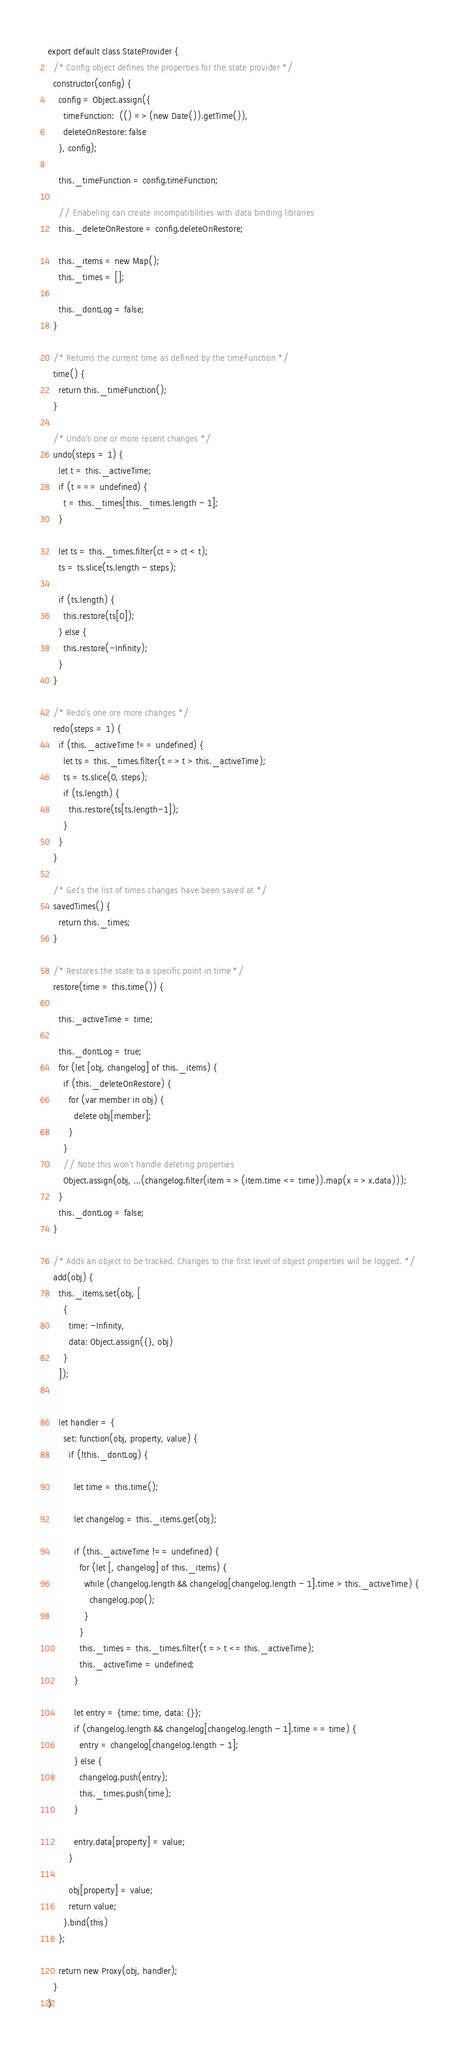Convert code to text. <code><loc_0><loc_0><loc_500><loc_500><_JavaScript_>export default class StateProvider {
  /* Config object defines the properties for the state provider */
  constructor(config) {
    config = Object.assign({
      timeFunction:  (() => (new Date()).getTime()),
      deleteOnRestore: false
    }, config);

    this._timeFunction = config.timeFunction;

    // Enabeling can create incompatibilities with data binding libraries
    this._deleteOnRestore = config.deleteOnRestore;

    this._items = new Map();
    this._times = [];

    this._dontLog = false;
  }

  /* Returns the current time as defined by the timeFunction */
  time() {
    return this._timeFunction();
  }

  /* Undo's one or more recent changes */
  undo(steps = 1) {
    let t = this._activeTime;
    if (t === undefined) {
      t = this._times[this._times.length - 1];
    }

    let ts = this._times.filter(ct => ct < t);
    ts = ts.slice(ts.length - steps);

    if (ts.length) {
      this.restore(ts[0]);
    } else {
      this.restore(-Infinity);
    }
  }

  /* Redo's one ore more changes */
  redo(steps = 1) {
    if (this._activeTime !== undefined) {
      let ts = this._times.filter(t => t > this._activeTime);
      ts = ts.slice(0, steps);
      if (ts.length) {
        this.restore(ts[ts.length-1]);
      }
    }
  }

  /* Get's the list of times changes have been saved at */
  savedTimes() {
    return this._times;
  }

  /* Restores the state to a specific point in time */
  restore(time = this.time()) {

    this._activeTime = time;

    this._dontLog = true;
    for (let [obj, changelog] of this._items) {
      if (this._deleteOnRestore) {
        for (var member in obj) {
          delete obj[member];
        }
      }
      // Note this won't handle deleting properties
      Object.assign(obj, ...(changelog.filter(item => (item.time <= time)).map(x => x.data)));
    }
    this._dontLog = false;
  }

  /* Adds an object to be tracked. Changes to the first level of object properties will be logged. */
  add(obj) {
    this._items.set(obj, [
      {
        time: -Infinity,
        data: Object.assign({}, obj)
      }
    ]);


    let handler = {
      set: function(obj, property, value) {
        if (!this._dontLog) {

          let time = this.time();

          let changelog = this._items.get(obj);

          if (this._activeTime !== undefined) {
            for (let [, changelog] of this._items) {
              while (changelog.length && changelog[changelog.length - 1].time > this._activeTime) {
                changelog.pop();
              }
            }
            this._times = this._times.filter(t => t <= this._activeTime);
            this._activeTime = undefined;
          }

          let entry = {time: time, data: {}};
          if (changelog.length && changelog[changelog.length - 1].time == time) {
            entry = changelog[changelog.length - 1];
          } else {
            changelog.push(entry);
            this._times.push(time);
          }

          entry.data[property] = value;
        }

        obj[property] = value;
        return value;
      }.bind(this)
    };

    return new Proxy(obj, handler);
  }
}
</code> 